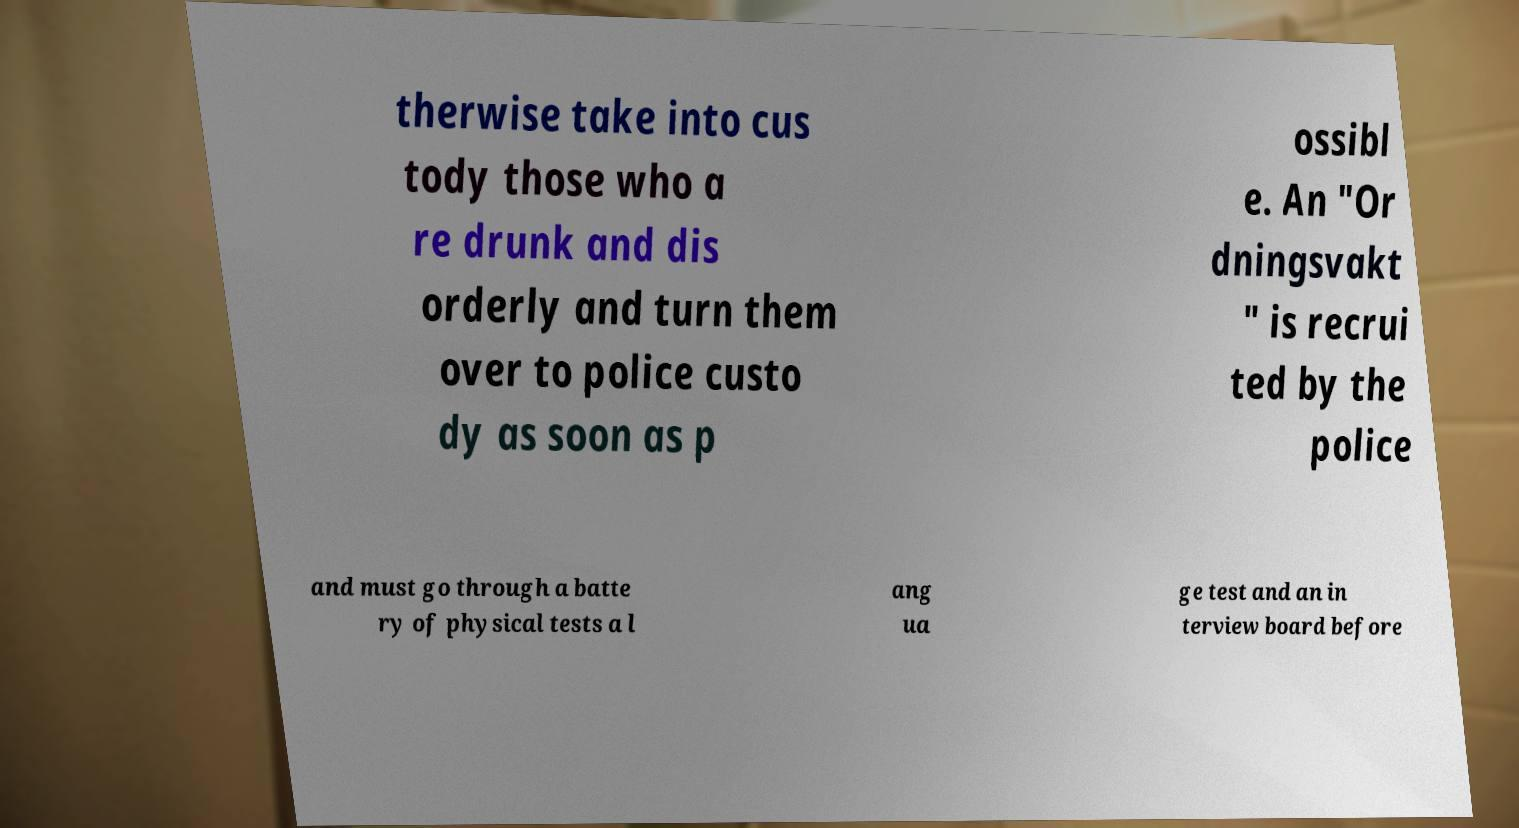Could you extract and type out the text from this image? therwise take into cus tody those who a re drunk and dis orderly and turn them over to police custo dy as soon as p ossibl e. An "Or dningsvakt " is recrui ted by the police and must go through a batte ry of physical tests a l ang ua ge test and an in terview board before 